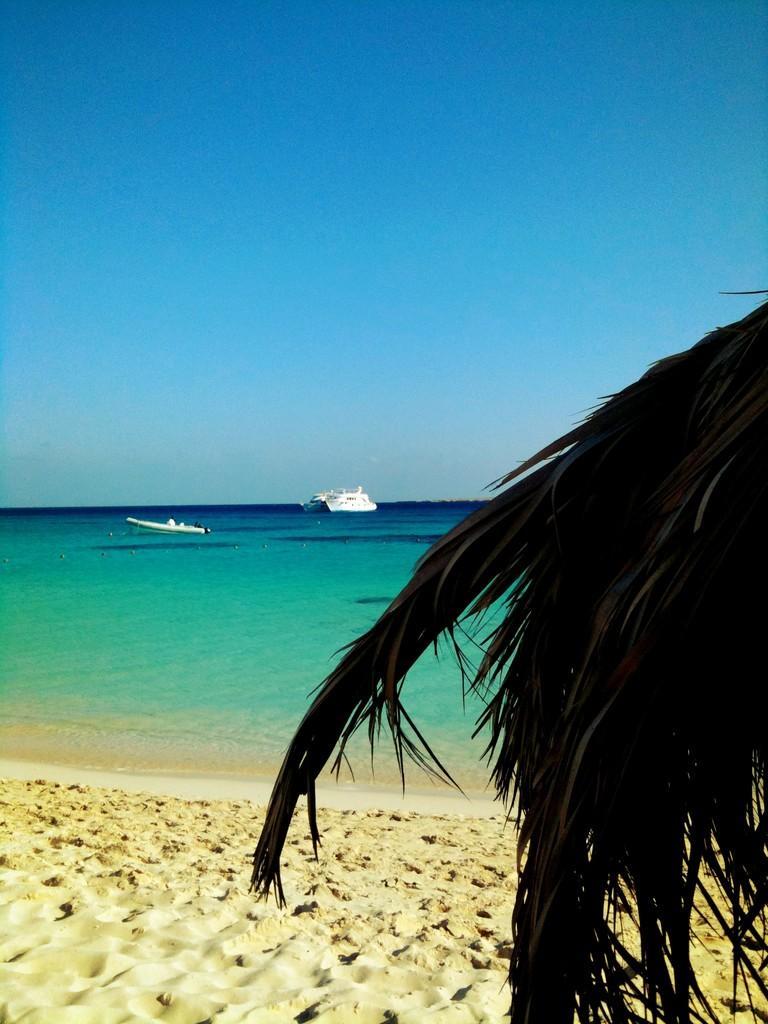Could you give a brief overview of what you see in this image? On the right side, we see the branch of a palm tree. At the bottom, we see the sand. In the background, we see water and this water might be in the sea. We see the boats sailing on the water. At the top, we see the sky, which is blue in color. This picture might be clicked at the beach. 